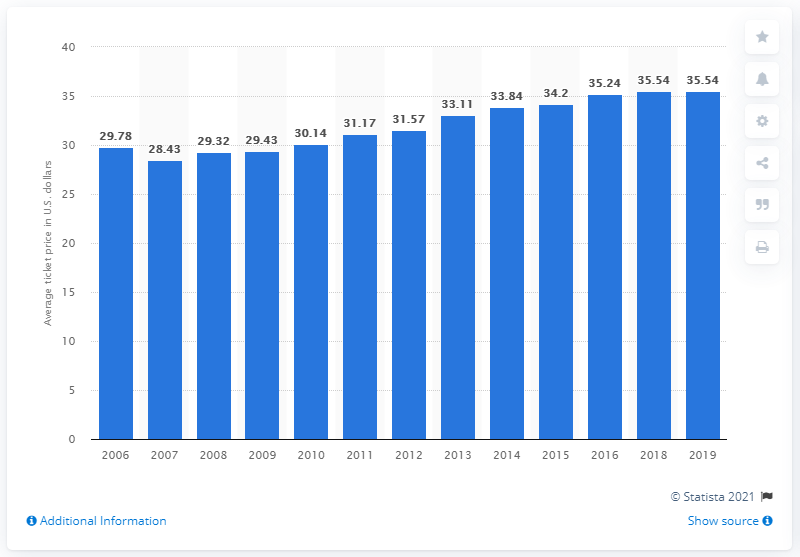Mention a couple of crucial points in this snapshot. The average ticket price for Cardinals games in 2019 was $35.54. 